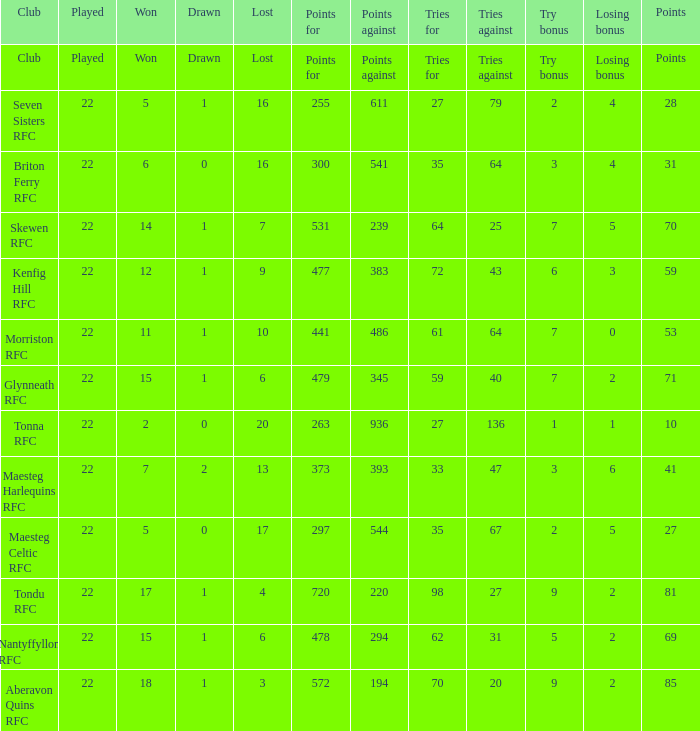What is the value of the points column when the value of the column lost is "lost" Points. 